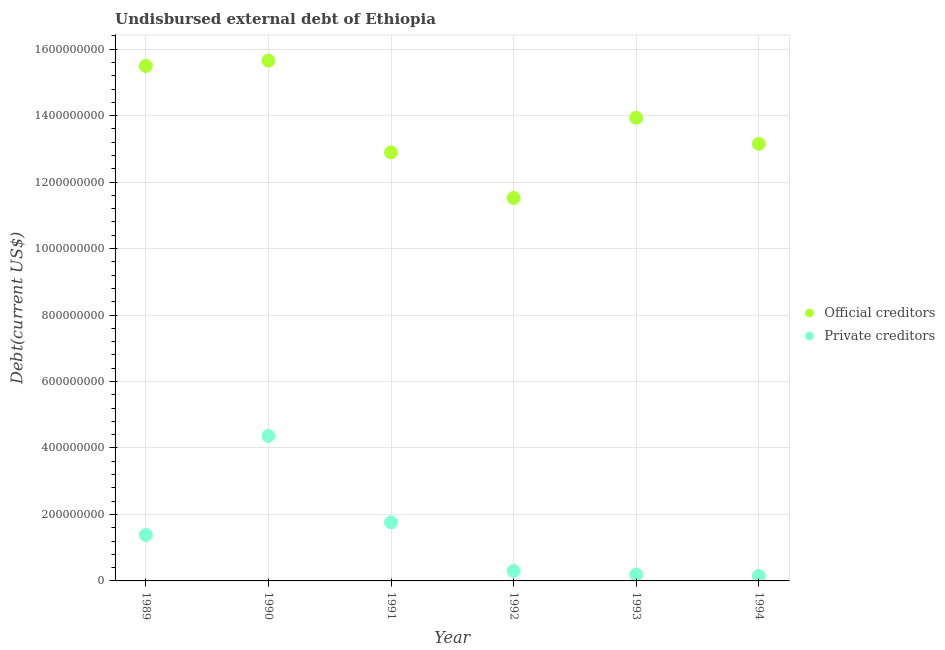Is the number of dotlines equal to the number of legend labels?
Your answer should be compact. Yes. What is the undisbursed external debt of official creditors in 1994?
Ensure brevity in your answer.  1.32e+09. Across all years, what is the maximum undisbursed external debt of private creditors?
Provide a succinct answer. 4.36e+08. Across all years, what is the minimum undisbursed external debt of official creditors?
Give a very brief answer. 1.15e+09. In which year was the undisbursed external debt of private creditors minimum?
Offer a very short reply. 1994. What is the total undisbursed external debt of private creditors in the graph?
Your answer should be very brief. 8.15e+08. What is the difference between the undisbursed external debt of official creditors in 1989 and that in 1991?
Give a very brief answer. 2.60e+08. What is the difference between the undisbursed external debt of private creditors in 1989 and the undisbursed external debt of official creditors in 1992?
Give a very brief answer. -1.01e+09. What is the average undisbursed external debt of private creditors per year?
Offer a very short reply. 1.36e+08. In the year 1993, what is the difference between the undisbursed external debt of private creditors and undisbursed external debt of official creditors?
Keep it short and to the point. -1.37e+09. What is the ratio of the undisbursed external debt of official creditors in 1992 to that in 1994?
Keep it short and to the point. 0.88. Is the difference between the undisbursed external debt of private creditors in 1990 and 1991 greater than the difference between the undisbursed external debt of official creditors in 1990 and 1991?
Your response must be concise. No. What is the difference between the highest and the second highest undisbursed external debt of private creditors?
Your response must be concise. 2.60e+08. What is the difference between the highest and the lowest undisbursed external debt of official creditors?
Offer a terse response. 4.13e+08. Is the sum of the undisbursed external debt of official creditors in 1990 and 1991 greater than the maximum undisbursed external debt of private creditors across all years?
Give a very brief answer. Yes. Is the undisbursed external debt of official creditors strictly greater than the undisbursed external debt of private creditors over the years?
Your response must be concise. Yes. How many years are there in the graph?
Make the answer very short. 6. Does the graph contain any zero values?
Your answer should be compact. No. Where does the legend appear in the graph?
Ensure brevity in your answer.  Center right. How are the legend labels stacked?
Ensure brevity in your answer.  Vertical. What is the title of the graph?
Give a very brief answer. Undisbursed external debt of Ethiopia. Does "Manufacturing industries and construction" appear as one of the legend labels in the graph?
Your answer should be compact. No. What is the label or title of the Y-axis?
Provide a succinct answer. Debt(current US$). What is the Debt(current US$) in Official creditors in 1989?
Keep it short and to the point. 1.55e+09. What is the Debt(current US$) of Private creditors in 1989?
Provide a short and direct response. 1.38e+08. What is the Debt(current US$) of Official creditors in 1990?
Offer a very short reply. 1.57e+09. What is the Debt(current US$) in Private creditors in 1990?
Offer a very short reply. 4.36e+08. What is the Debt(current US$) of Official creditors in 1991?
Provide a succinct answer. 1.29e+09. What is the Debt(current US$) in Private creditors in 1991?
Provide a short and direct response. 1.76e+08. What is the Debt(current US$) of Official creditors in 1992?
Your answer should be very brief. 1.15e+09. What is the Debt(current US$) of Private creditors in 1992?
Offer a terse response. 3.00e+07. What is the Debt(current US$) of Official creditors in 1993?
Make the answer very short. 1.39e+09. What is the Debt(current US$) in Private creditors in 1993?
Your answer should be very brief. 1.93e+07. What is the Debt(current US$) of Official creditors in 1994?
Offer a terse response. 1.32e+09. What is the Debt(current US$) of Private creditors in 1994?
Your answer should be compact. 1.51e+07. Across all years, what is the maximum Debt(current US$) in Official creditors?
Make the answer very short. 1.57e+09. Across all years, what is the maximum Debt(current US$) in Private creditors?
Provide a short and direct response. 4.36e+08. Across all years, what is the minimum Debt(current US$) in Official creditors?
Provide a succinct answer. 1.15e+09. Across all years, what is the minimum Debt(current US$) of Private creditors?
Provide a succinct answer. 1.51e+07. What is the total Debt(current US$) in Official creditors in the graph?
Offer a terse response. 8.26e+09. What is the total Debt(current US$) in Private creditors in the graph?
Provide a succinct answer. 8.15e+08. What is the difference between the Debt(current US$) in Official creditors in 1989 and that in 1990?
Give a very brief answer. -1.60e+07. What is the difference between the Debt(current US$) in Private creditors in 1989 and that in 1990?
Provide a short and direct response. -2.98e+08. What is the difference between the Debt(current US$) in Official creditors in 1989 and that in 1991?
Ensure brevity in your answer.  2.60e+08. What is the difference between the Debt(current US$) of Private creditors in 1989 and that in 1991?
Your response must be concise. -3.80e+07. What is the difference between the Debt(current US$) of Official creditors in 1989 and that in 1992?
Keep it short and to the point. 3.97e+08. What is the difference between the Debt(current US$) in Private creditors in 1989 and that in 1992?
Your answer should be compact. 1.08e+08. What is the difference between the Debt(current US$) of Official creditors in 1989 and that in 1993?
Provide a succinct answer. 1.56e+08. What is the difference between the Debt(current US$) of Private creditors in 1989 and that in 1993?
Keep it short and to the point. 1.19e+08. What is the difference between the Debt(current US$) in Official creditors in 1989 and that in 1994?
Offer a very short reply. 2.34e+08. What is the difference between the Debt(current US$) of Private creditors in 1989 and that in 1994?
Keep it short and to the point. 1.23e+08. What is the difference between the Debt(current US$) of Official creditors in 1990 and that in 1991?
Offer a very short reply. 2.76e+08. What is the difference between the Debt(current US$) in Private creditors in 1990 and that in 1991?
Keep it short and to the point. 2.60e+08. What is the difference between the Debt(current US$) in Official creditors in 1990 and that in 1992?
Offer a terse response. 4.13e+08. What is the difference between the Debt(current US$) in Private creditors in 1990 and that in 1992?
Offer a terse response. 4.06e+08. What is the difference between the Debt(current US$) of Official creditors in 1990 and that in 1993?
Keep it short and to the point. 1.72e+08. What is the difference between the Debt(current US$) in Private creditors in 1990 and that in 1993?
Your response must be concise. 4.17e+08. What is the difference between the Debt(current US$) of Official creditors in 1990 and that in 1994?
Keep it short and to the point. 2.50e+08. What is the difference between the Debt(current US$) in Private creditors in 1990 and that in 1994?
Make the answer very short. 4.21e+08. What is the difference between the Debt(current US$) of Official creditors in 1991 and that in 1992?
Ensure brevity in your answer.  1.37e+08. What is the difference between the Debt(current US$) in Private creditors in 1991 and that in 1992?
Your answer should be compact. 1.46e+08. What is the difference between the Debt(current US$) of Official creditors in 1991 and that in 1993?
Your answer should be very brief. -1.04e+08. What is the difference between the Debt(current US$) in Private creditors in 1991 and that in 1993?
Offer a very short reply. 1.57e+08. What is the difference between the Debt(current US$) of Official creditors in 1991 and that in 1994?
Keep it short and to the point. -2.59e+07. What is the difference between the Debt(current US$) of Private creditors in 1991 and that in 1994?
Offer a very short reply. 1.61e+08. What is the difference between the Debt(current US$) of Official creditors in 1992 and that in 1993?
Keep it short and to the point. -2.41e+08. What is the difference between the Debt(current US$) of Private creditors in 1992 and that in 1993?
Make the answer very short. 1.08e+07. What is the difference between the Debt(current US$) in Official creditors in 1992 and that in 1994?
Keep it short and to the point. -1.63e+08. What is the difference between the Debt(current US$) of Private creditors in 1992 and that in 1994?
Your response must be concise. 1.50e+07. What is the difference between the Debt(current US$) of Official creditors in 1993 and that in 1994?
Your answer should be compact. 7.82e+07. What is the difference between the Debt(current US$) of Private creditors in 1993 and that in 1994?
Make the answer very short. 4.21e+06. What is the difference between the Debt(current US$) in Official creditors in 1989 and the Debt(current US$) in Private creditors in 1990?
Your response must be concise. 1.11e+09. What is the difference between the Debt(current US$) of Official creditors in 1989 and the Debt(current US$) of Private creditors in 1991?
Your response must be concise. 1.37e+09. What is the difference between the Debt(current US$) of Official creditors in 1989 and the Debt(current US$) of Private creditors in 1992?
Offer a terse response. 1.52e+09. What is the difference between the Debt(current US$) of Official creditors in 1989 and the Debt(current US$) of Private creditors in 1993?
Provide a short and direct response. 1.53e+09. What is the difference between the Debt(current US$) of Official creditors in 1989 and the Debt(current US$) of Private creditors in 1994?
Your answer should be compact. 1.53e+09. What is the difference between the Debt(current US$) of Official creditors in 1990 and the Debt(current US$) of Private creditors in 1991?
Offer a terse response. 1.39e+09. What is the difference between the Debt(current US$) of Official creditors in 1990 and the Debt(current US$) of Private creditors in 1992?
Provide a succinct answer. 1.54e+09. What is the difference between the Debt(current US$) of Official creditors in 1990 and the Debt(current US$) of Private creditors in 1993?
Keep it short and to the point. 1.55e+09. What is the difference between the Debt(current US$) in Official creditors in 1990 and the Debt(current US$) in Private creditors in 1994?
Ensure brevity in your answer.  1.55e+09. What is the difference between the Debt(current US$) of Official creditors in 1991 and the Debt(current US$) of Private creditors in 1992?
Ensure brevity in your answer.  1.26e+09. What is the difference between the Debt(current US$) in Official creditors in 1991 and the Debt(current US$) in Private creditors in 1993?
Provide a short and direct response. 1.27e+09. What is the difference between the Debt(current US$) of Official creditors in 1991 and the Debt(current US$) of Private creditors in 1994?
Your answer should be compact. 1.27e+09. What is the difference between the Debt(current US$) of Official creditors in 1992 and the Debt(current US$) of Private creditors in 1993?
Ensure brevity in your answer.  1.13e+09. What is the difference between the Debt(current US$) of Official creditors in 1992 and the Debt(current US$) of Private creditors in 1994?
Offer a terse response. 1.14e+09. What is the difference between the Debt(current US$) of Official creditors in 1993 and the Debt(current US$) of Private creditors in 1994?
Make the answer very short. 1.38e+09. What is the average Debt(current US$) of Official creditors per year?
Offer a very short reply. 1.38e+09. What is the average Debt(current US$) of Private creditors per year?
Offer a terse response. 1.36e+08. In the year 1989, what is the difference between the Debt(current US$) in Official creditors and Debt(current US$) in Private creditors?
Provide a succinct answer. 1.41e+09. In the year 1990, what is the difference between the Debt(current US$) in Official creditors and Debt(current US$) in Private creditors?
Give a very brief answer. 1.13e+09. In the year 1991, what is the difference between the Debt(current US$) of Official creditors and Debt(current US$) of Private creditors?
Make the answer very short. 1.11e+09. In the year 1992, what is the difference between the Debt(current US$) in Official creditors and Debt(current US$) in Private creditors?
Keep it short and to the point. 1.12e+09. In the year 1993, what is the difference between the Debt(current US$) of Official creditors and Debt(current US$) of Private creditors?
Your answer should be compact. 1.37e+09. In the year 1994, what is the difference between the Debt(current US$) of Official creditors and Debt(current US$) of Private creditors?
Provide a succinct answer. 1.30e+09. What is the ratio of the Debt(current US$) in Official creditors in 1989 to that in 1990?
Your response must be concise. 0.99. What is the ratio of the Debt(current US$) in Private creditors in 1989 to that in 1990?
Your answer should be compact. 0.32. What is the ratio of the Debt(current US$) of Official creditors in 1989 to that in 1991?
Offer a very short reply. 1.2. What is the ratio of the Debt(current US$) of Private creditors in 1989 to that in 1991?
Make the answer very short. 0.78. What is the ratio of the Debt(current US$) of Official creditors in 1989 to that in 1992?
Provide a short and direct response. 1.34. What is the ratio of the Debt(current US$) of Private creditors in 1989 to that in 1992?
Make the answer very short. 4.6. What is the ratio of the Debt(current US$) of Official creditors in 1989 to that in 1993?
Provide a short and direct response. 1.11. What is the ratio of the Debt(current US$) of Private creditors in 1989 to that in 1993?
Offer a terse response. 7.17. What is the ratio of the Debt(current US$) in Official creditors in 1989 to that in 1994?
Ensure brevity in your answer.  1.18. What is the ratio of the Debt(current US$) of Private creditors in 1989 to that in 1994?
Ensure brevity in your answer.  9.17. What is the ratio of the Debt(current US$) in Official creditors in 1990 to that in 1991?
Keep it short and to the point. 1.21. What is the ratio of the Debt(current US$) in Private creditors in 1990 to that in 1991?
Your response must be concise. 2.47. What is the ratio of the Debt(current US$) of Official creditors in 1990 to that in 1992?
Your response must be concise. 1.36. What is the ratio of the Debt(current US$) in Private creditors in 1990 to that in 1992?
Your answer should be compact. 14.52. What is the ratio of the Debt(current US$) of Official creditors in 1990 to that in 1993?
Ensure brevity in your answer.  1.12. What is the ratio of the Debt(current US$) of Private creditors in 1990 to that in 1993?
Offer a very short reply. 22.62. What is the ratio of the Debt(current US$) in Official creditors in 1990 to that in 1994?
Give a very brief answer. 1.19. What is the ratio of the Debt(current US$) in Private creditors in 1990 to that in 1994?
Make the answer very short. 28.93. What is the ratio of the Debt(current US$) of Official creditors in 1991 to that in 1992?
Give a very brief answer. 1.12. What is the ratio of the Debt(current US$) of Private creditors in 1991 to that in 1992?
Your answer should be very brief. 5.87. What is the ratio of the Debt(current US$) in Official creditors in 1991 to that in 1993?
Offer a very short reply. 0.93. What is the ratio of the Debt(current US$) of Private creditors in 1991 to that in 1993?
Provide a succinct answer. 9.14. What is the ratio of the Debt(current US$) of Official creditors in 1991 to that in 1994?
Provide a short and direct response. 0.98. What is the ratio of the Debt(current US$) of Private creditors in 1991 to that in 1994?
Provide a short and direct response. 11.69. What is the ratio of the Debt(current US$) in Official creditors in 1992 to that in 1993?
Give a very brief answer. 0.83. What is the ratio of the Debt(current US$) of Private creditors in 1992 to that in 1993?
Offer a terse response. 1.56. What is the ratio of the Debt(current US$) of Official creditors in 1992 to that in 1994?
Your answer should be compact. 0.88. What is the ratio of the Debt(current US$) in Private creditors in 1992 to that in 1994?
Give a very brief answer. 1.99. What is the ratio of the Debt(current US$) of Official creditors in 1993 to that in 1994?
Your response must be concise. 1.06. What is the ratio of the Debt(current US$) in Private creditors in 1993 to that in 1994?
Your response must be concise. 1.28. What is the difference between the highest and the second highest Debt(current US$) in Official creditors?
Give a very brief answer. 1.60e+07. What is the difference between the highest and the second highest Debt(current US$) of Private creditors?
Your answer should be very brief. 2.60e+08. What is the difference between the highest and the lowest Debt(current US$) of Official creditors?
Keep it short and to the point. 4.13e+08. What is the difference between the highest and the lowest Debt(current US$) in Private creditors?
Ensure brevity in your answer.  4.21e+08. 